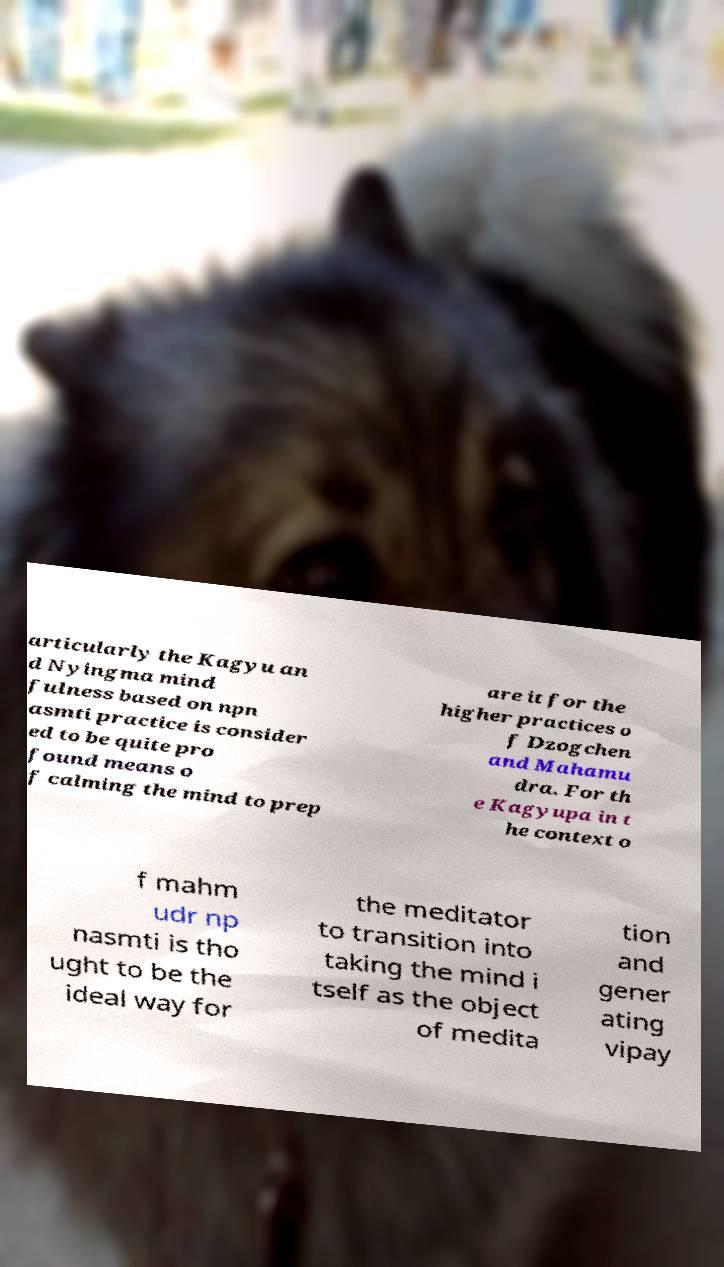I need the written content from this picture converted into text. Can you do that? articularly the Kagyu an d Nyingma mind fulness based on npn asmti practice is consider ed to be quite pro found means o f calming the mind to prep are it for the higher practices o f Dzogchen and Mahamu dra. For th e Kagyupa in t he context o f mahm udr np nasmti is tho ught to be the ideal way for the meditator to transition into taking the mind i tself as the object of medita tion and gener ating vipay 